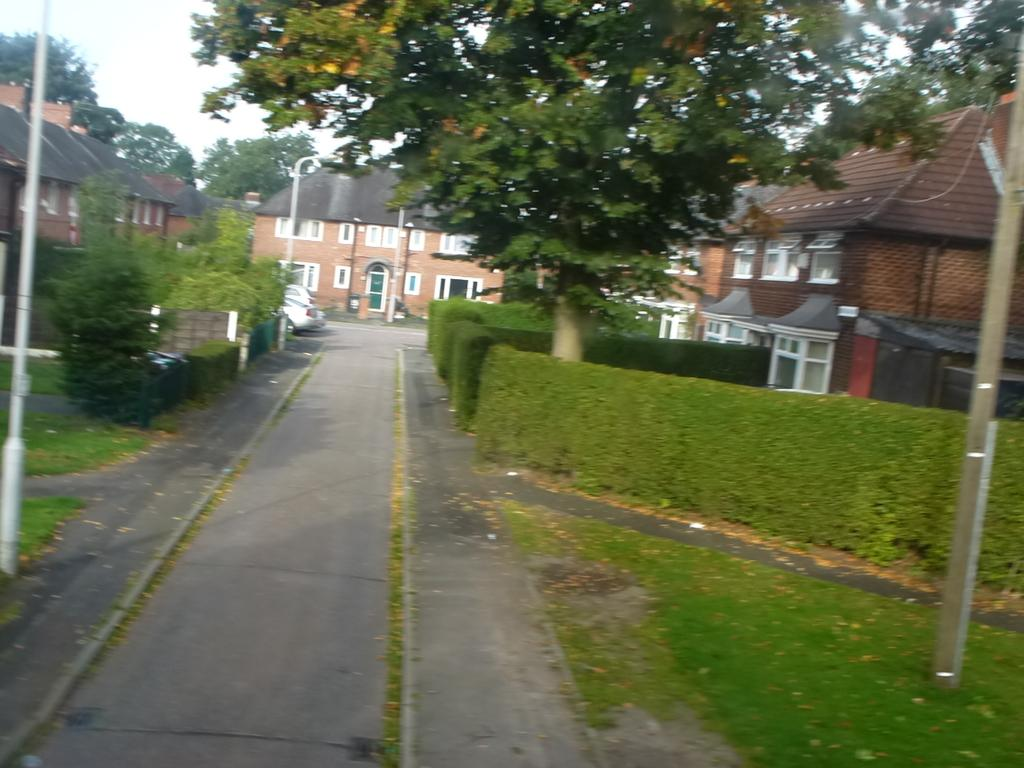What type of surface can be seen in the image? There is a road in the image. What type of vegetation is present in the image? Grass, plants, and trees are in the image. What can be seen moving along the road in the image? Vehicles are visible in the image. What structures are present in the image? Poles, a fence, and buildings with windows are in the image. What is visible in the background of the image? The sky is visible in the background of the image. What type of record can be heard playing in the background of the image? There is no record playing in the background of the image; it is a still image with no sound. Who is the expert in the image? There is no expert present in the image; it is a scene with various objects and structures. 